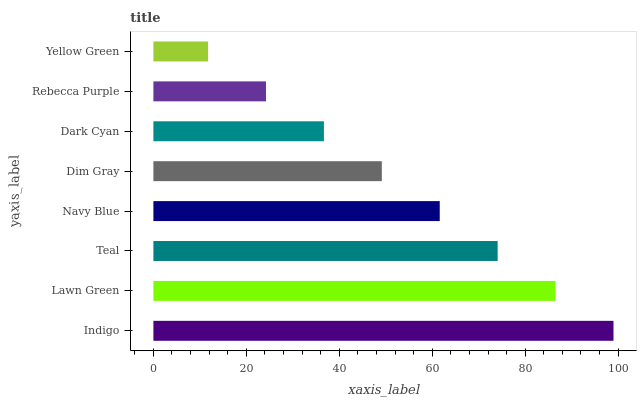Is Yellow Green the minimum?
Answer yes or no. Yes. Is Indigo the maximum?
Answer yes or no. Yes. Is Lawn Green the minimum?
Answer yes or no. No. Is Lawn Green the maximum?
Answer yes or no. No. Is Indigo greater than Lawn Green?
Answer yes or no. Yes. Is Lawn Green less than Indigo?
Answer yes or no. Yes. Is Lawn Green greater than Indigo?
Answer yes or no. No. Is Indigo less than Lawn Green?
Answer yes or no. No. Is Navy Blue the high median?
Answer yes or no. Yes. Is Dim Gray the low median?
Answer yes or no. Yes. Is Dark Cyan the high median?
Answer yes or no. No. Is Navy Blue the low median?
Answer yes or no. No. 